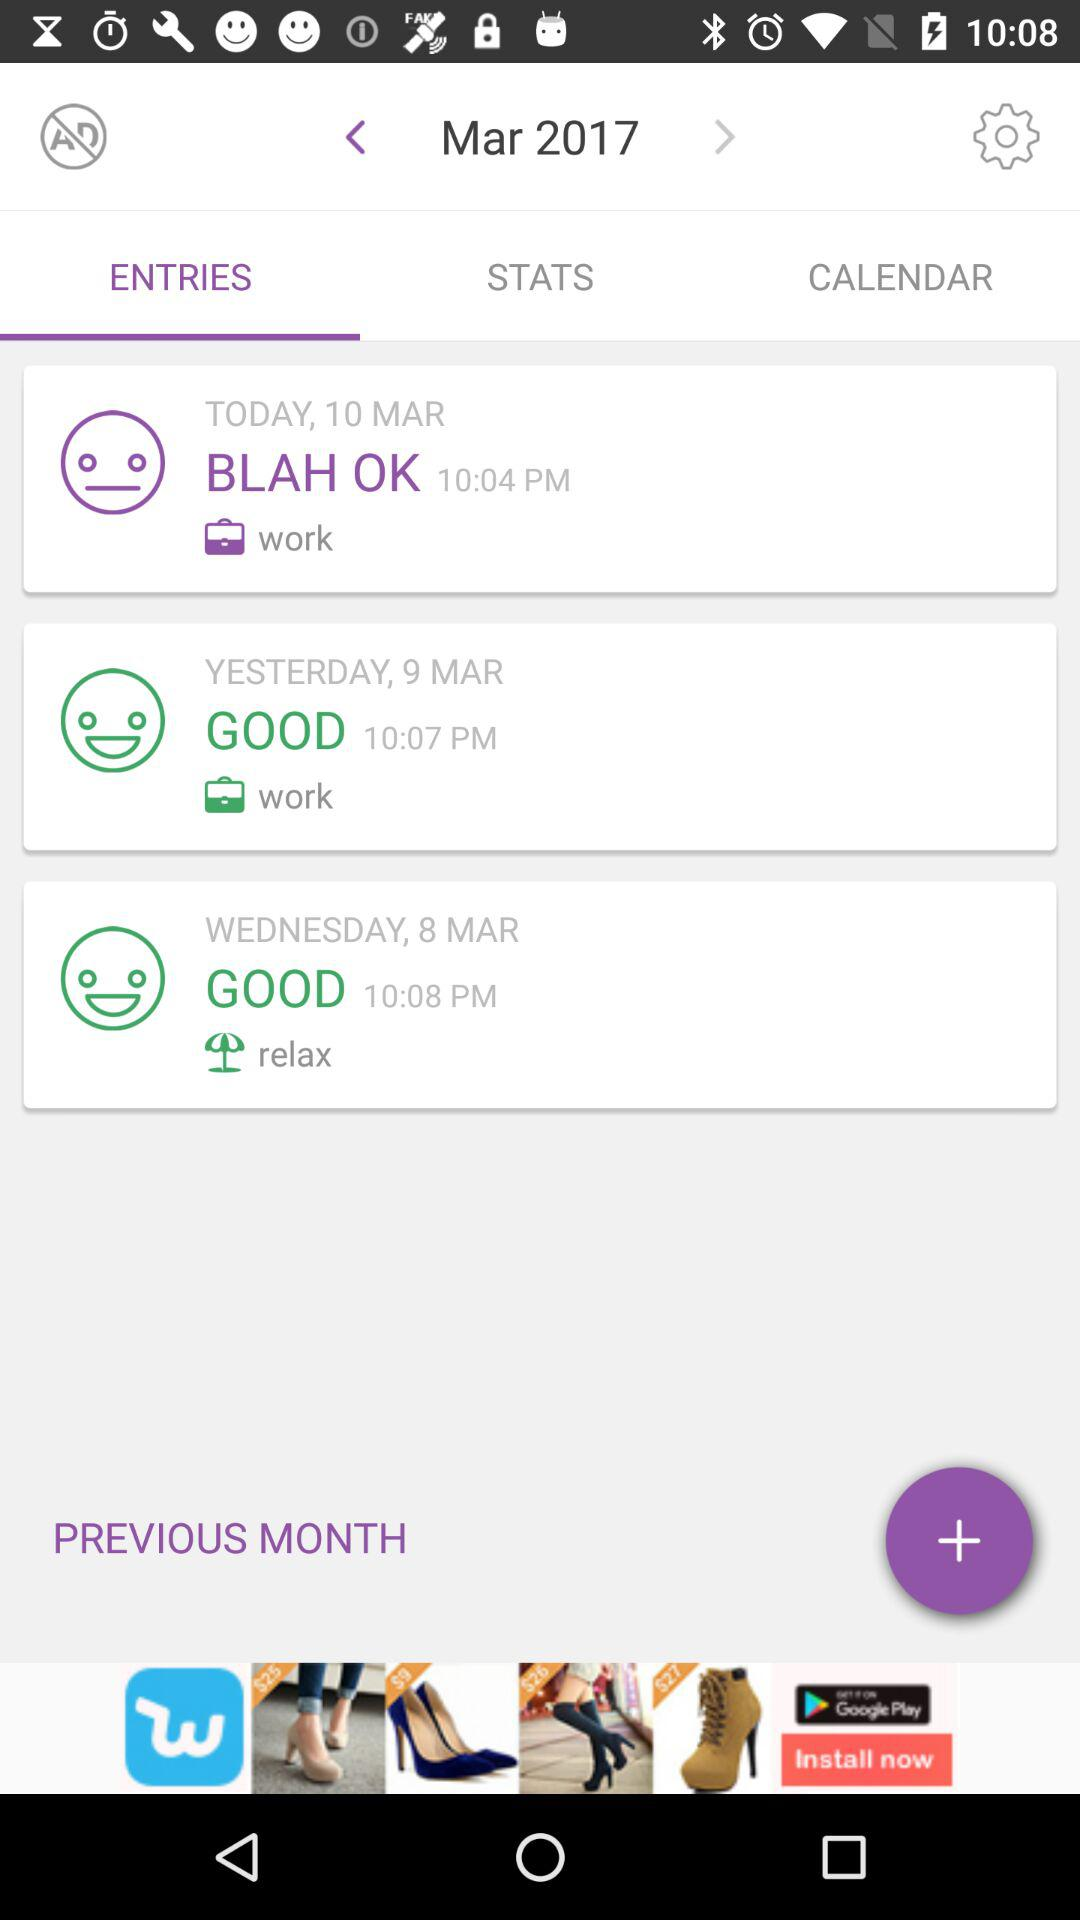What time was the entry made on the 10th of March? The entry was made at 10:04 PM. 